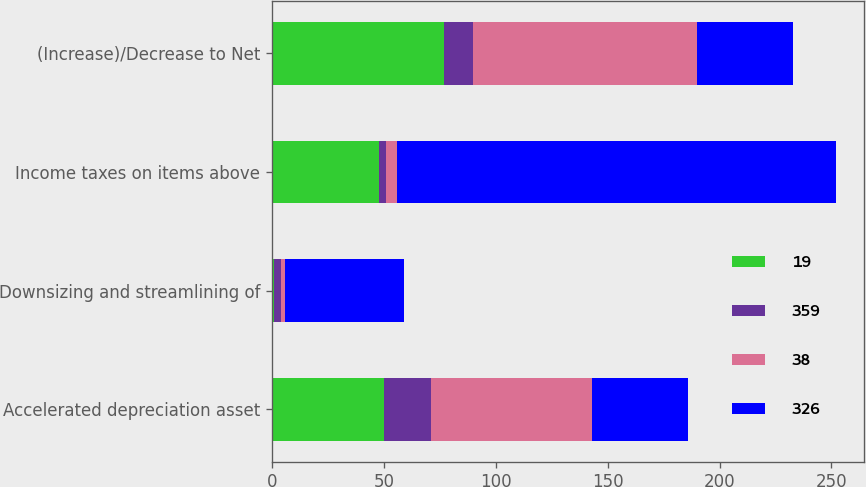Convert chart to OTSL. <chart><loc_0><loc_0><loc_500><loc_500><stacked_bar_chart><ecel><fcel>Accelerated depreciation asset<fcel>Downsizing and streamlining of<fcel>Income taxes on items above<fcel>(Increase)/Decrease to Net<nl><fcel>19<fcel>50<fcel>1<fcel>48<fcel>77<nl><fcel>359<fcel>21<fcel>3<fcel>3<fcel>13<nl><fcel>38<fcel>72<fcel>2<fcel>5<fcel>100<nl><fcel>326<fcel>43<fcel>53<fcel>196<fcel>43<nl></chart> 